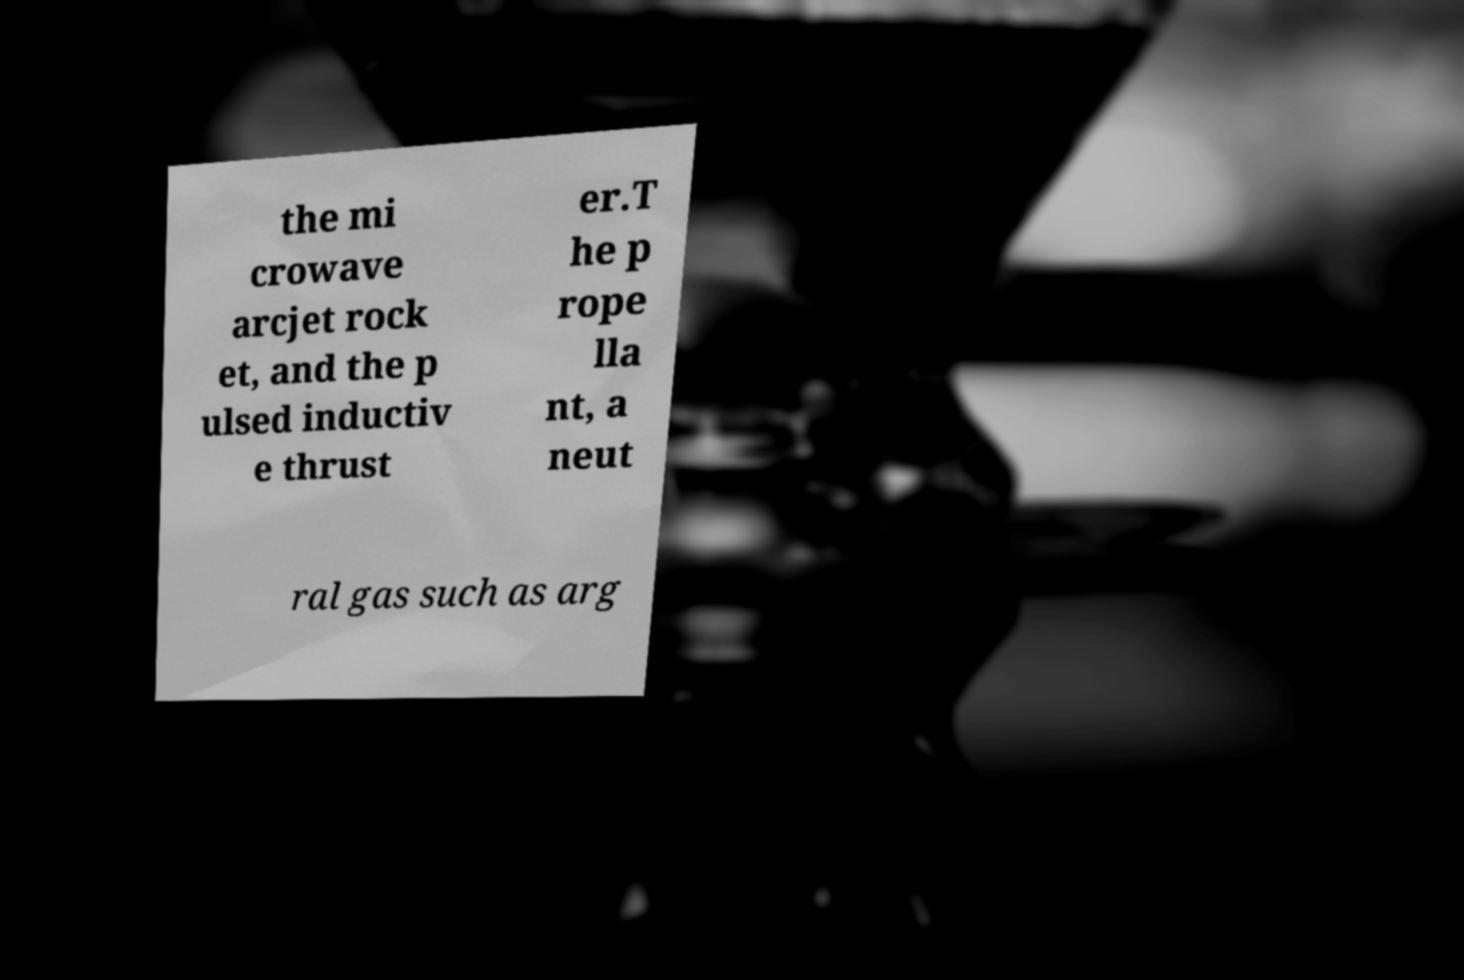For documentation purposes, I need the text within this image transcribed. Could you provide that? the mi crowave arcjet rock et, and the p ulsed inductiv e thrust er.T he p rope lla nt, a neut ral gas such as arg 